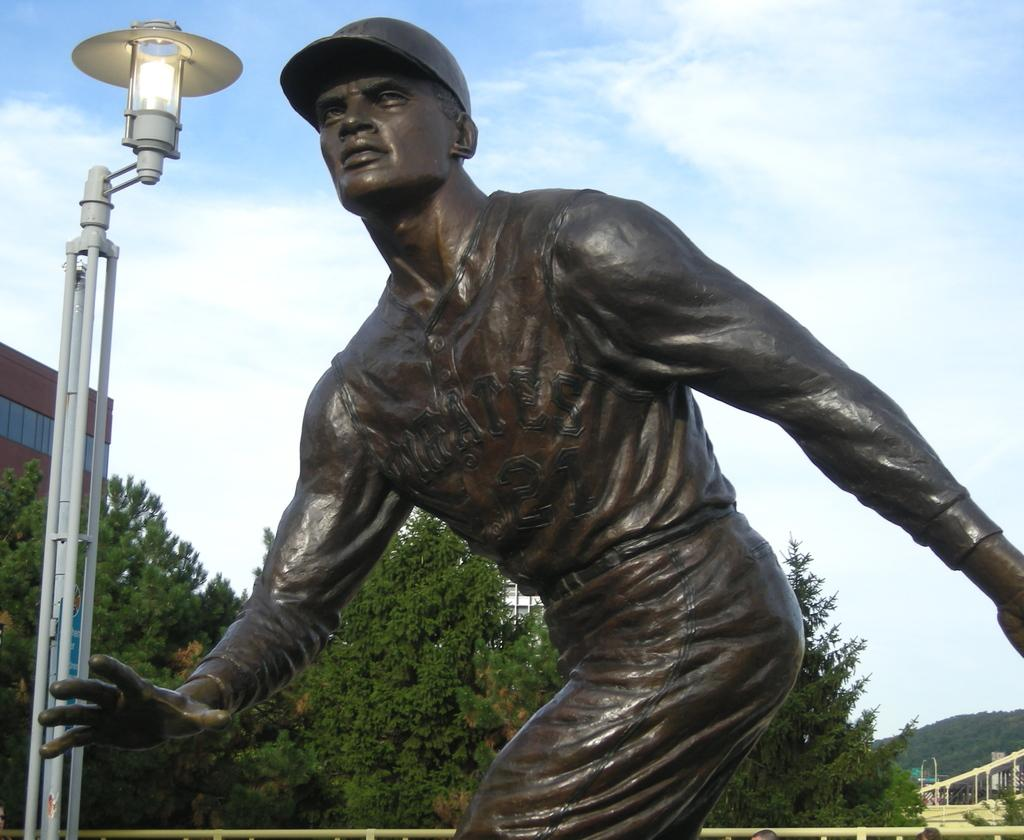What is the main subject in the center of the image? There is a statue in the center of the image. What can be seen in the background of the image? There are trees in the background of the image. What object is located on the left side of the image? There is a pole on the left side of the image. Can you tell me how many women are holding a bit and a rifle in the image? There are no women, bits, or rifles present in the image. 